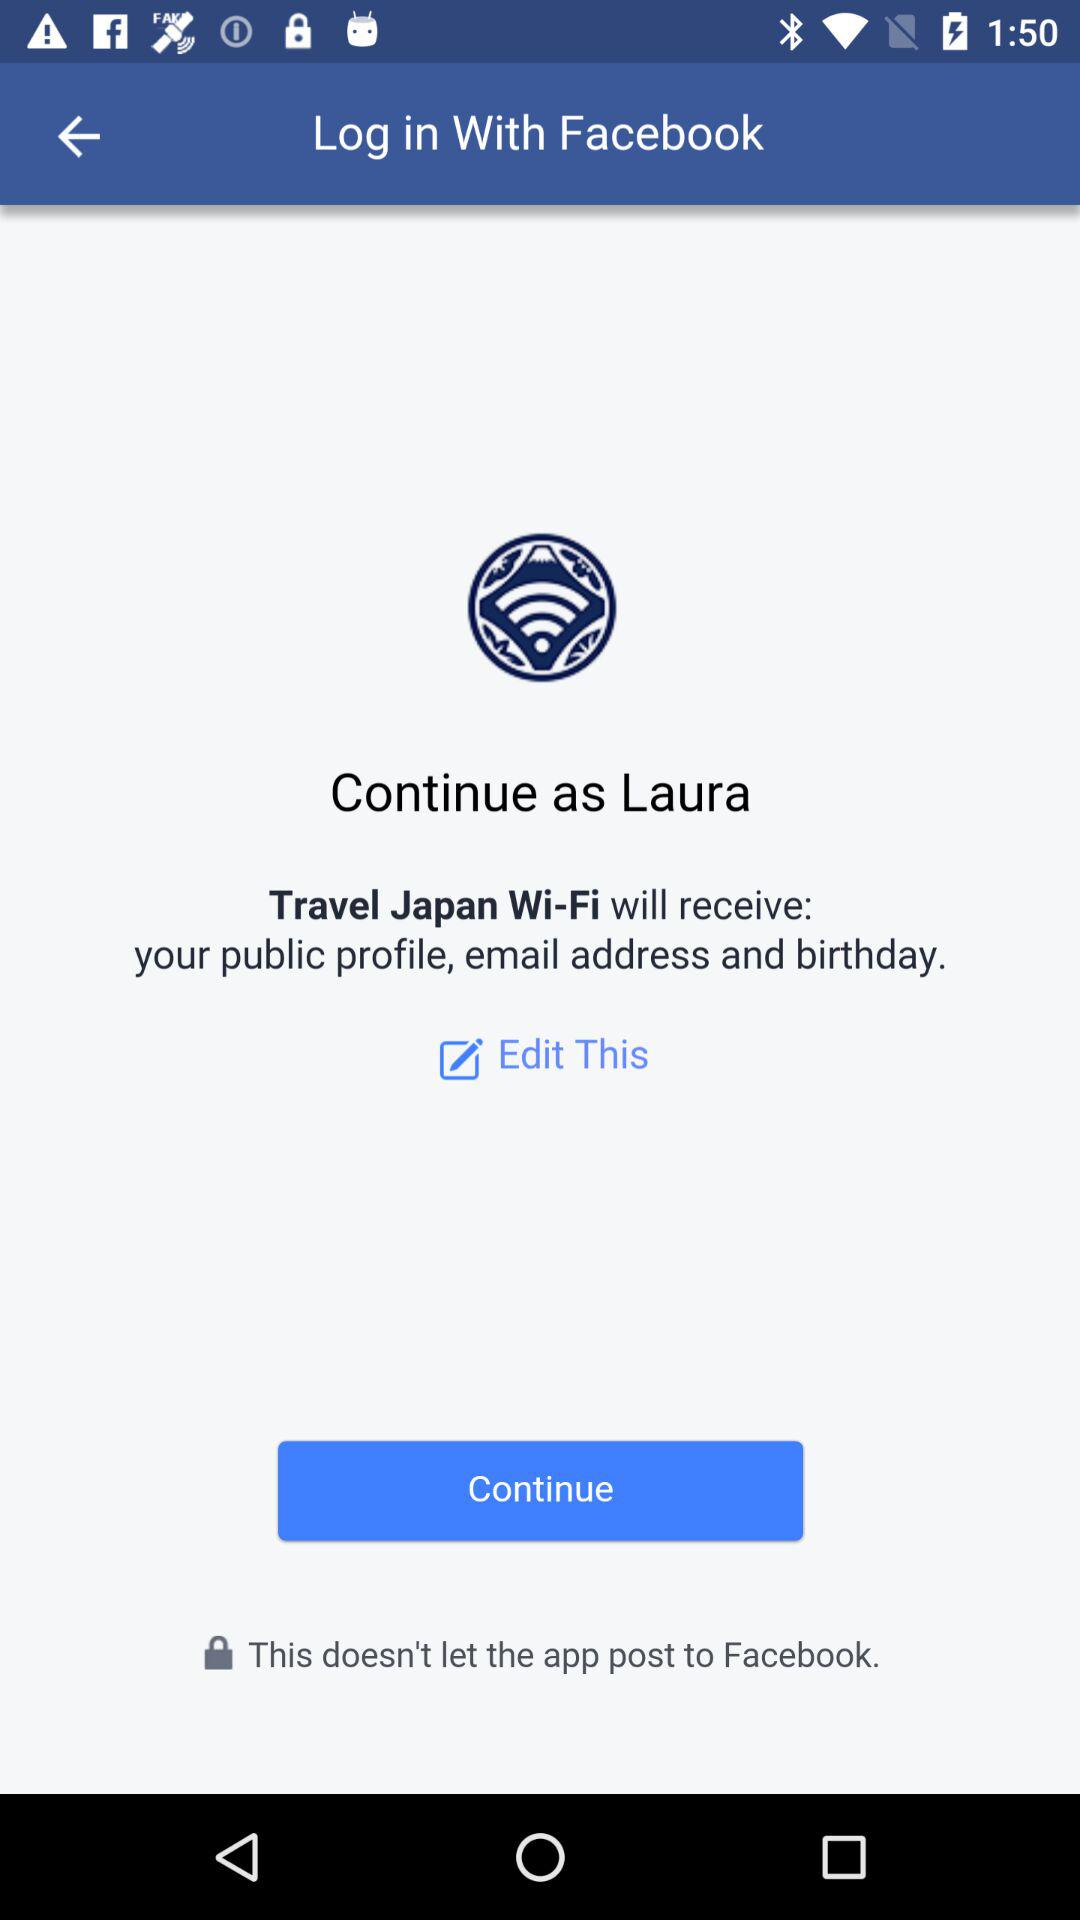With which application can we log in? You can log in with "Facebook". 